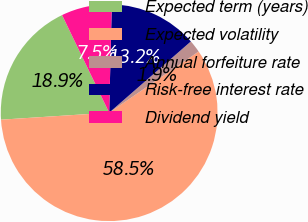Convert chart to OTSL. <chart><loc_0><loc_0><loc_500><loc_500><pie_chart><fcel>Expected term (years)<fcel>Expected volatility<fcel>Annual forfeiture rate<fcel>Risk-free interest rate<fcel>Dividend yield<nl><fcel>18.87%<fcel>58.52%<fcel>1.87%<fcel>13.2%<fcel>7.54%<nl></chart> 